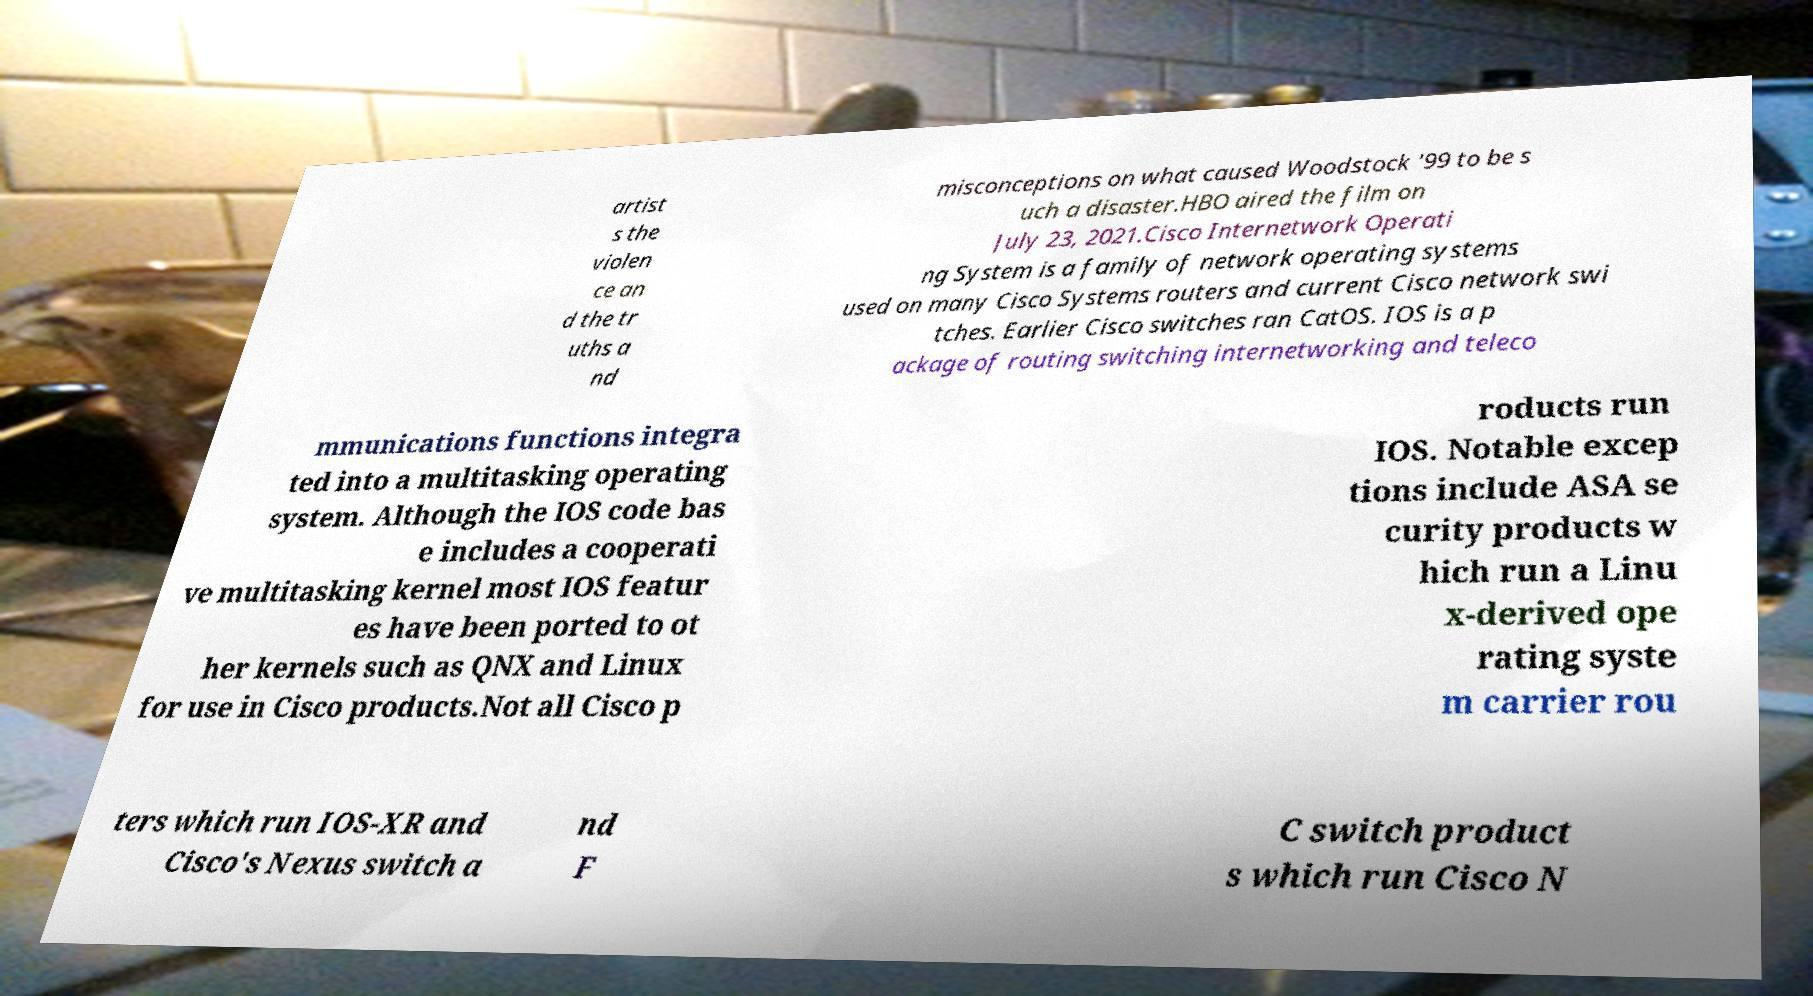What messages or text are displayed in this image? I need them in a readable, typed format. artist s the violen ce an d the tr uths a nd misconceptions on what caused Woodstock '99 to be s uch a disaster.HBO aired the film on July 23, 2021.Cisco Internetwork Operati ng System is a family of network operating systems used on many Cisco Systems routers and current Cisco network swi tches. Earlier Cisco switches ran CatOS. IOS is a p ackage of routing switching internetworking and teleco mmunications functions integra ted into a multitasking operating system. Although the IOS code bas e includes a cooperati ve multitasking kernel most IOS featur es have been ported to ot her kernels such as QNX and Linux for use in Cisco products.Not all Cisco p roducts run IOS. Notable excep tions include ASA se curity products w hich run a Linu x-derived ope rating syste m carrier rou ters which run IOS-XR and Cisco's Nexus switch a nd F C switch product s which run Cisco N 